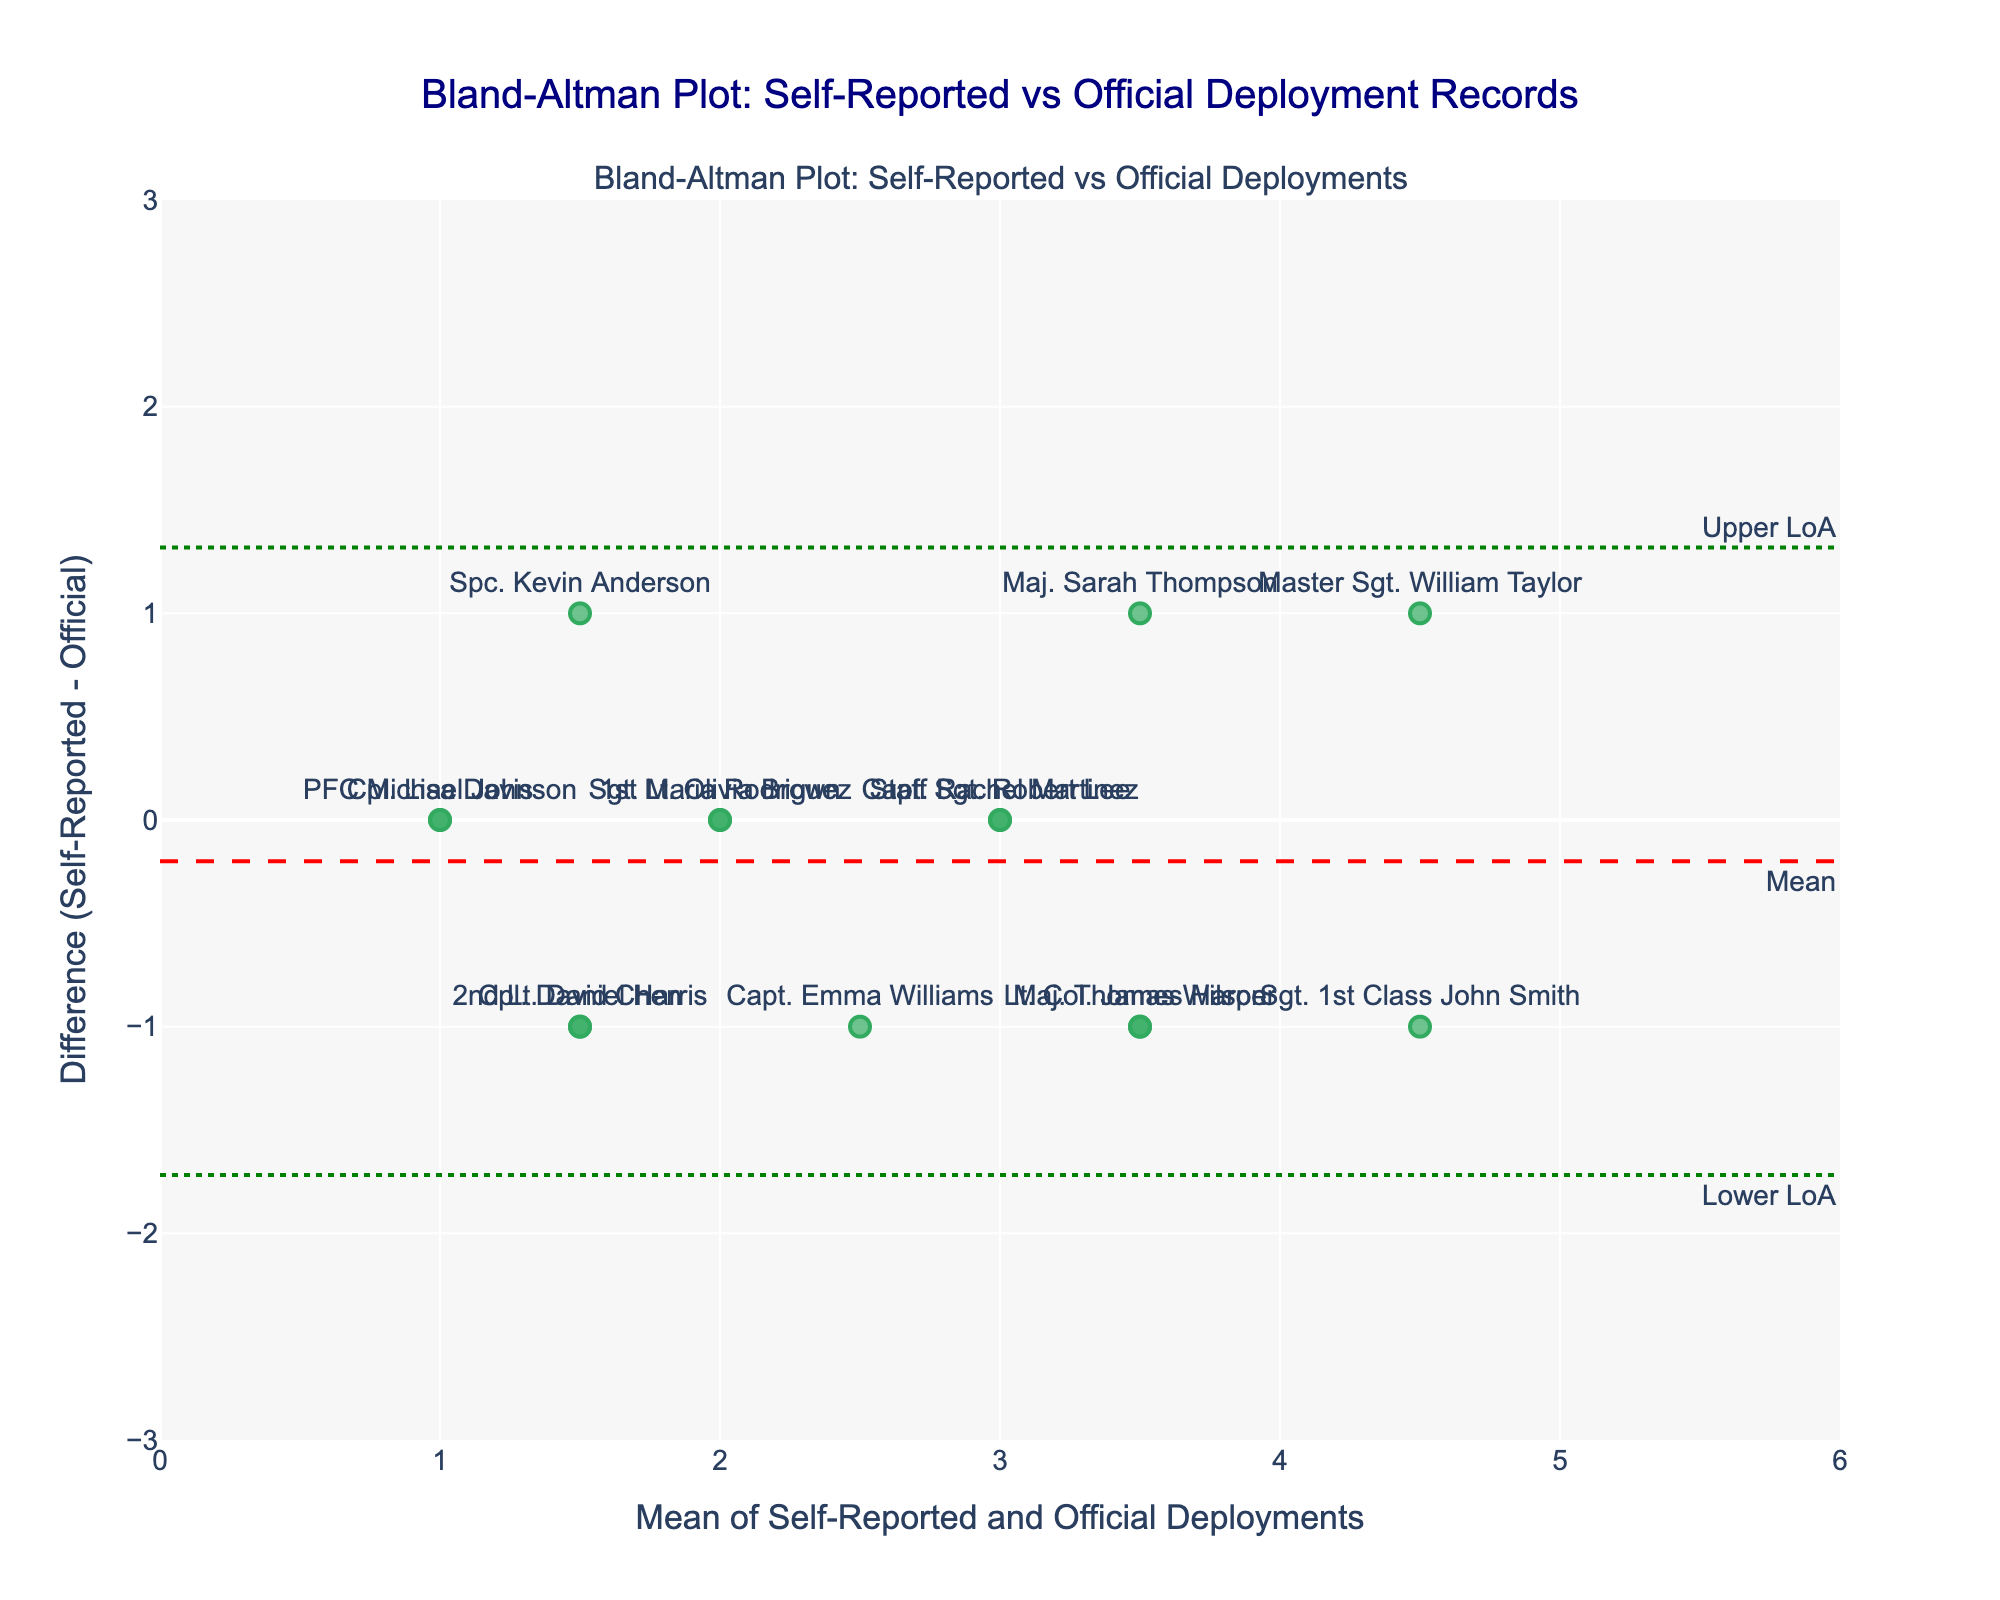What is the title of the Bland-Altman plot? The title is located at the top of the figure where it summarizes the overall purpose of the plot, indicating what comparison is being made.
Answer: Bland-Altman Plot: Self-Reported vs Official Deployment Records What is the mean difference between self-reported and official records? The mean difference line is highlighted with a red dashed line and labeled as "Mean" on the plot's y-axis.
Answer: Approximately -0.13 What are the upper and lower limits of agreement? The upper and lower limits are marked with green dotted lines on the plot, each labeled as "Upper LoA" and "Lower LoA".
Answer: Upper: 1.54, Lower: -1.80 How many soldiers have a difference of zero between self-reported and official deployments? Find the data points on the plot where the y-value (difference) is zero, indicating perfect agreement between the two records.
Answer: Four soldiers Which soldier reported the highest number of deployments according to official records? Locate the furthest data point to the right on the x-axis, then identify the corresponding soldier from the plot's text labels.
Answer: Master Sgt. William Taylor For which soldier is the discrepancy between self-reported and official deployments the greatest? Look for the data point with the highest absolute y-value (difference), then identify the corresponding soldier from the plot's text labels.
Answer: Master Sgt. William Taylor How many soldiers reported fewer deployments in self-reported records compared to official records? Count the number of data points below the zero line (negative y-value) which represent under-reporting in self-reported records.
Answer: Six soldiers Which soldier had the largest positive difference (self-reported higher than official records)? Look for the data point with the highest positive y-value (difference), then identify the corresponding soldier from the plot's text labels.
Answer: Spc. Kevin Anderson What is the range of the x-axis (mean of self-reported and official deployments)? Examine the x-axis from where it starts to where it ends to determine the range of mean values plotted.
Answer: 0 to 6 What does the y-axis represent in this Bland-Altman plot? The y-axis is labeled and represents the difference between self-reported and official deployments (self-reported minus official).
Answer: Difference (Self-Reported - Official) 